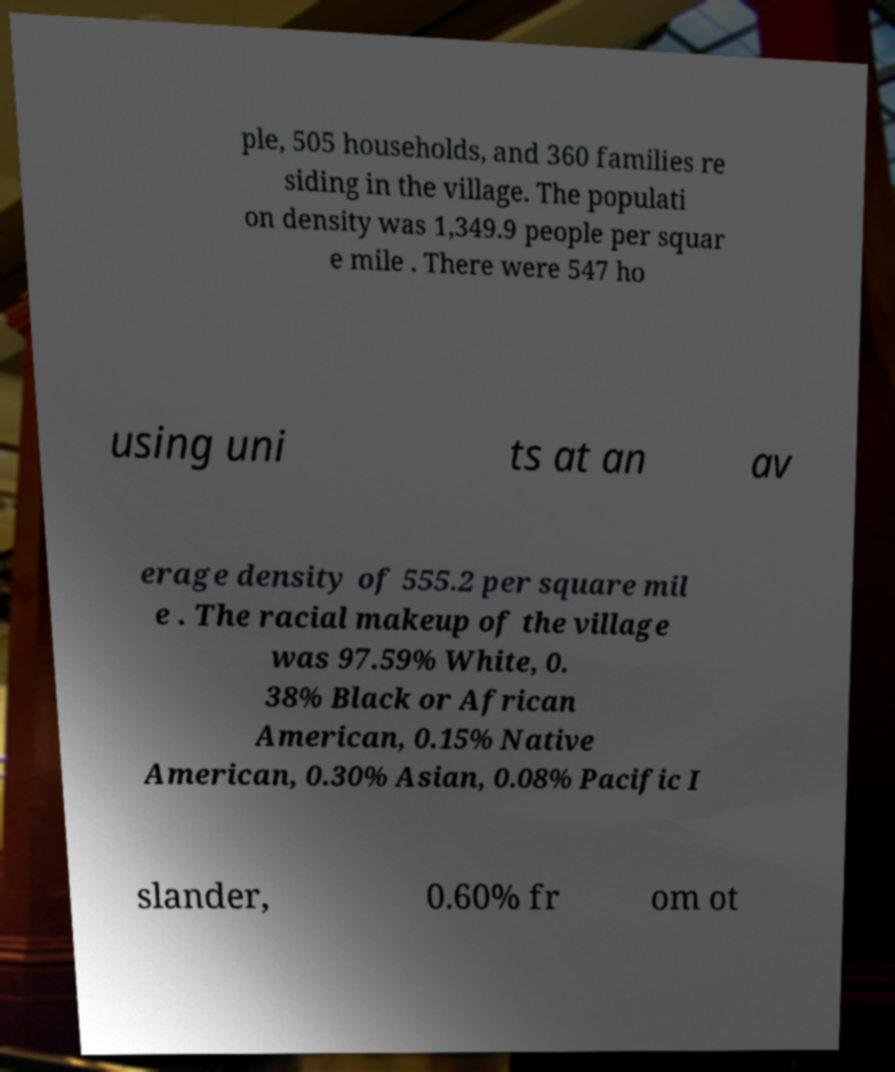There's text embedded in this image that I need extracted. Can you transcribe it verbatim? ple, 505 households, and 360 families re siding in the village. The populati on density was 1,349.9 people per squar e mile . There were 547 ho using uni ts at an av erage density of 555.2 per square mil e . The racial makeup of the village was 97.59% White, 0. 38% Black or African American, 0.15% Native American, 0.30% Asian, 0.08% Pacific I slander, 0.60% fr om ot 